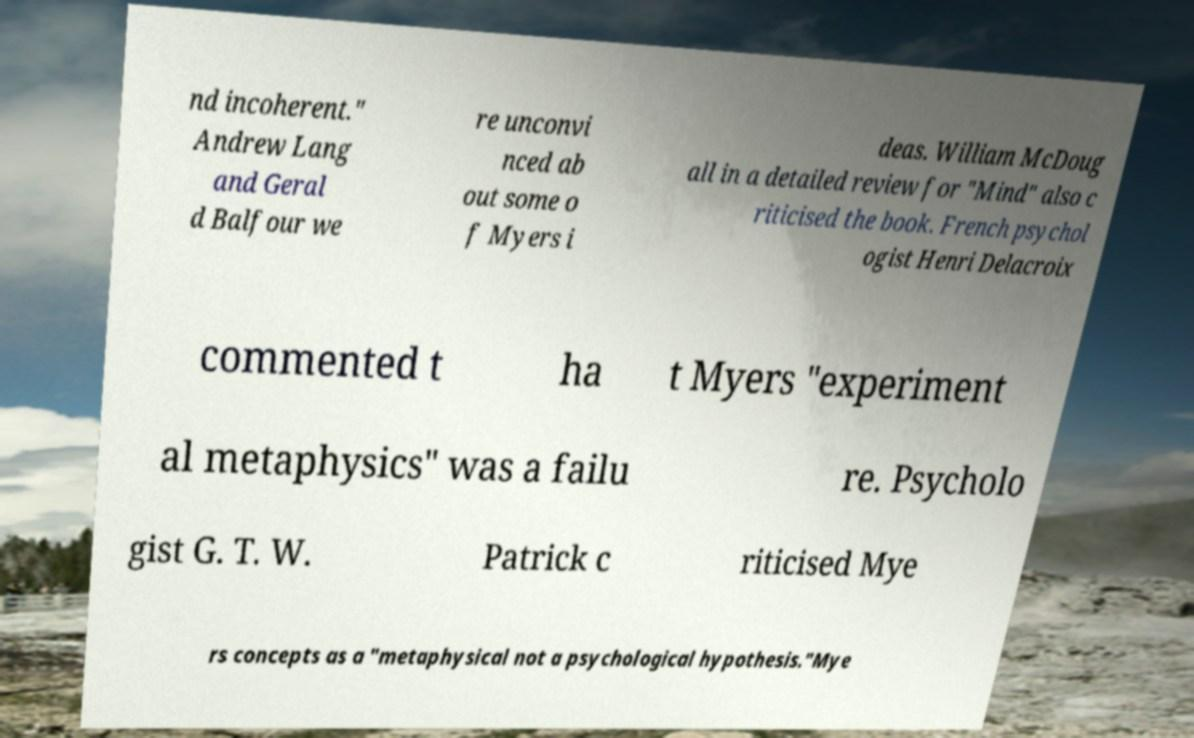Can you accurately transcribe the text from the provided image for me? nd incoherent." Andrew Lang and Geral d Balfour we re unconvi nced ab out some o f Myers i deas. William McDoug all in a detailed review for "Mind" also c riticised the book. French psychol ogist Henri Delacroix commented t ha t Myers "experiment al metaphysics" was a failu re. Psycholo gist G. T. W. Patrick c riticised Mye rs concepts as a "metaphysical not a psychological hypothesis."Mye 